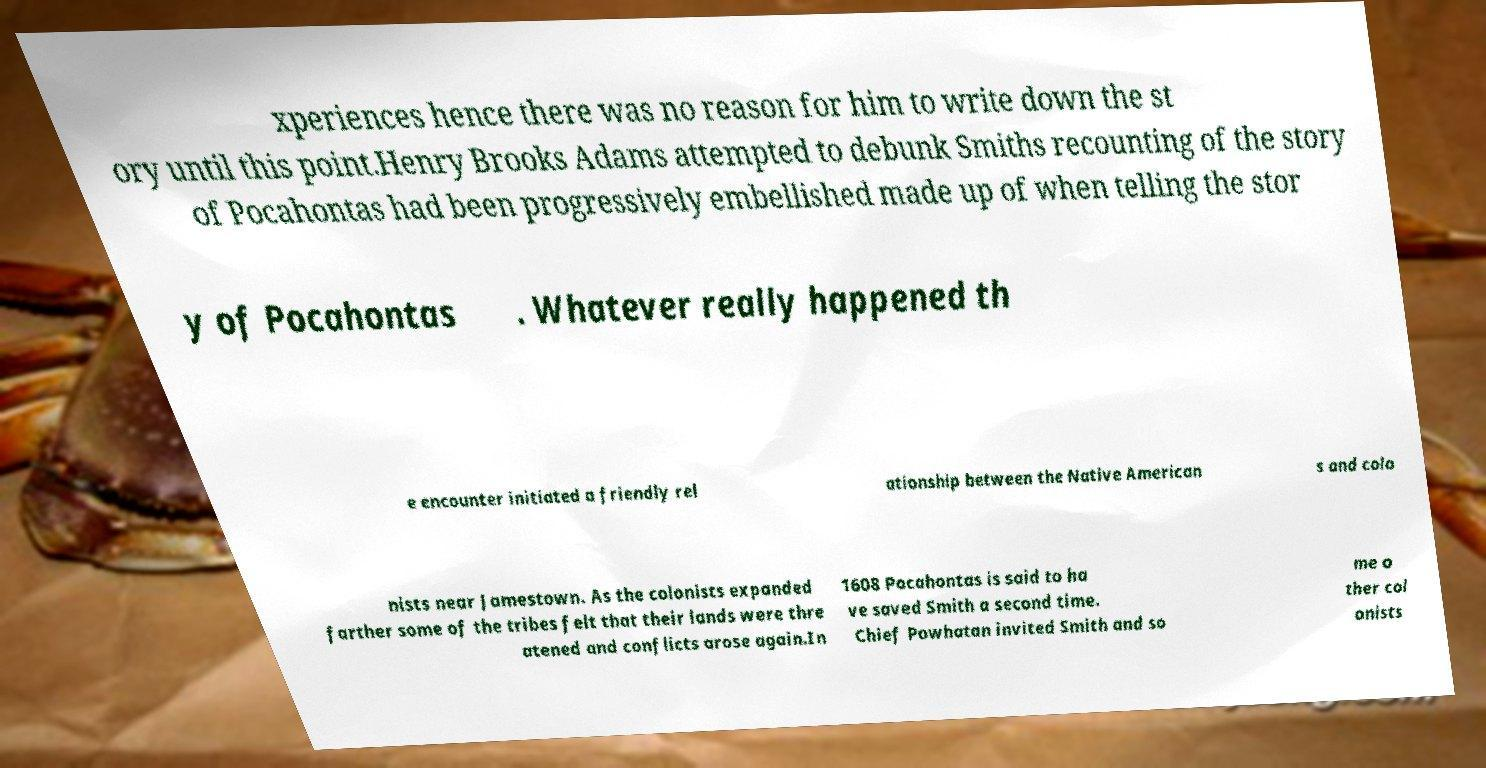Please identify and transcribe the text found in this image. xperiences hence there was no reason for him to write down the st ory until this point.Henry Brooks Adams attempted to debunk Smiths recounting of the story of Pocahontas had been progressively embellished made up of when telling the stor y of Pocahontas . Whatever really happened th e encounter initiated a friendly rel ationship between the Native American s and colo nists near Jamestown. As the colonists expanded farther some of the tribes felt that their lands were thre atened and conflicts arose again.In 1608 Pocahontas is said to ha ve saved Smith a second time. Chief Powhatan invited Smith and so me o ther col onists 